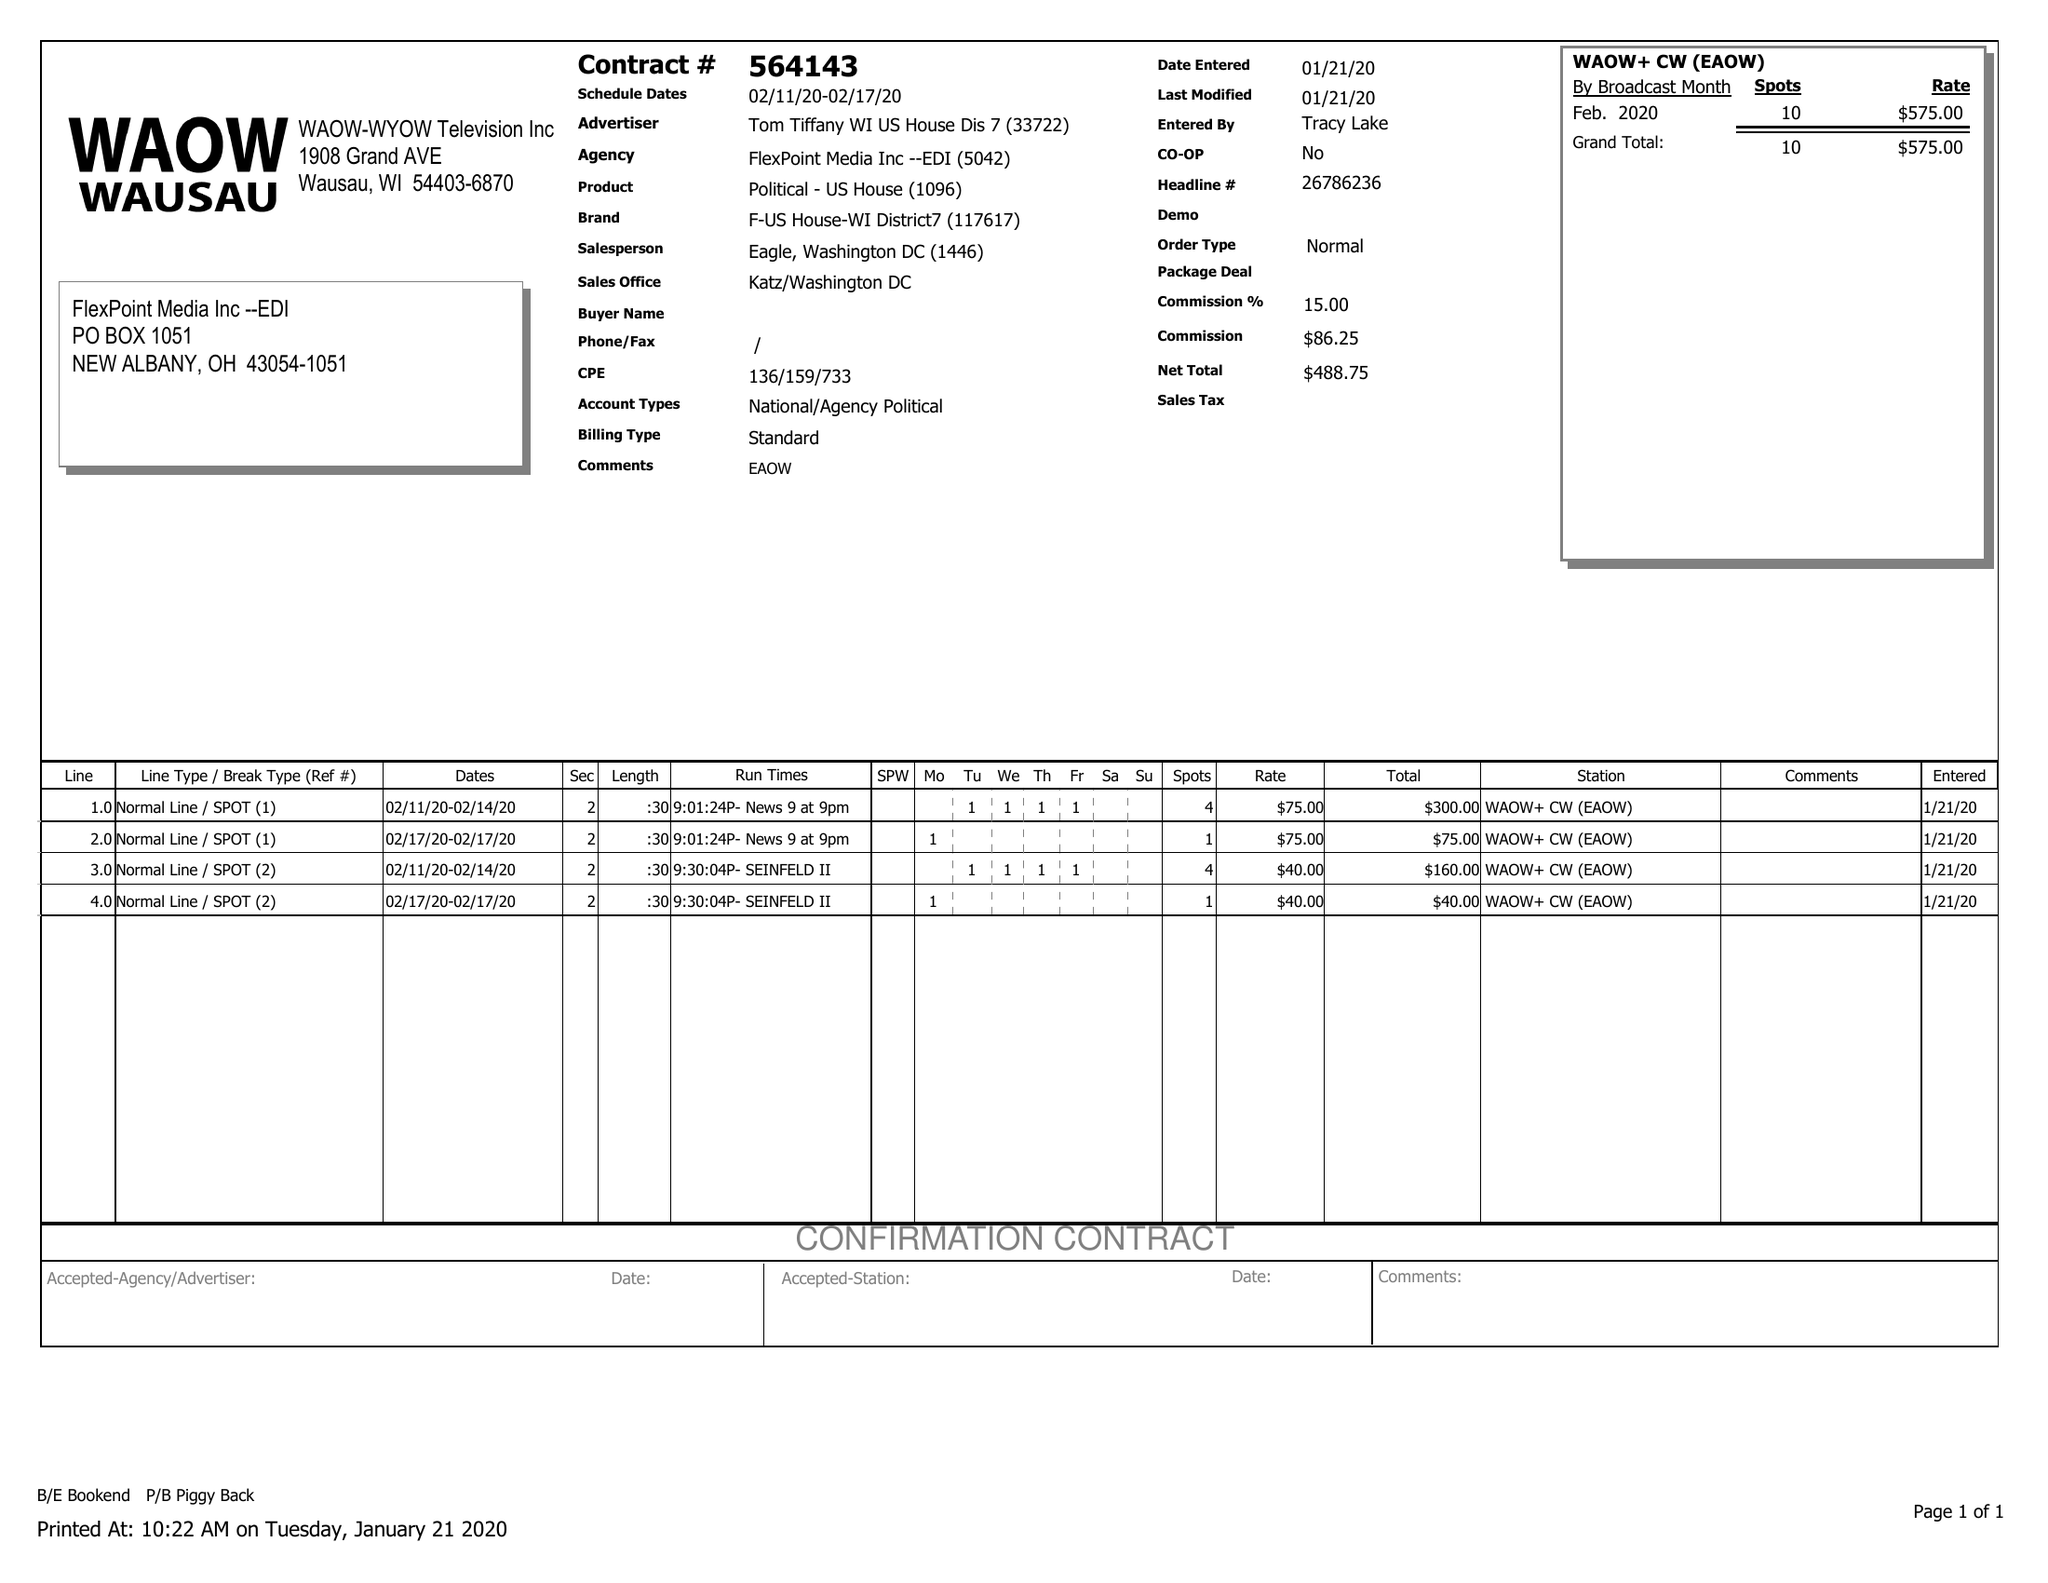What is the value for the flight_to?
Answer the question using a single word or phrase. 02/17/20 